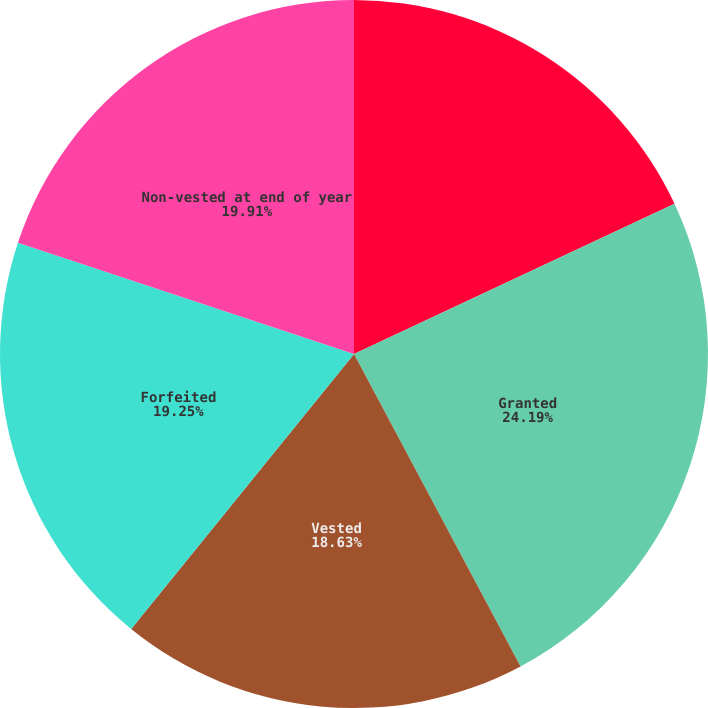Convert chart to OTSL. <chart><loc_0><loc_0><loc_500><loc_500><pie_chart><fcel>Non-vested at beginning of<fcel>Granted<fcel>Vested<fcel>Forfeited<fcel>Non-vested at end of year<nl><fcel>18.02%<fcel>24.18%<fcel>18.63%<fcel>19.25%<fcel>19.91%<nl></chart> 